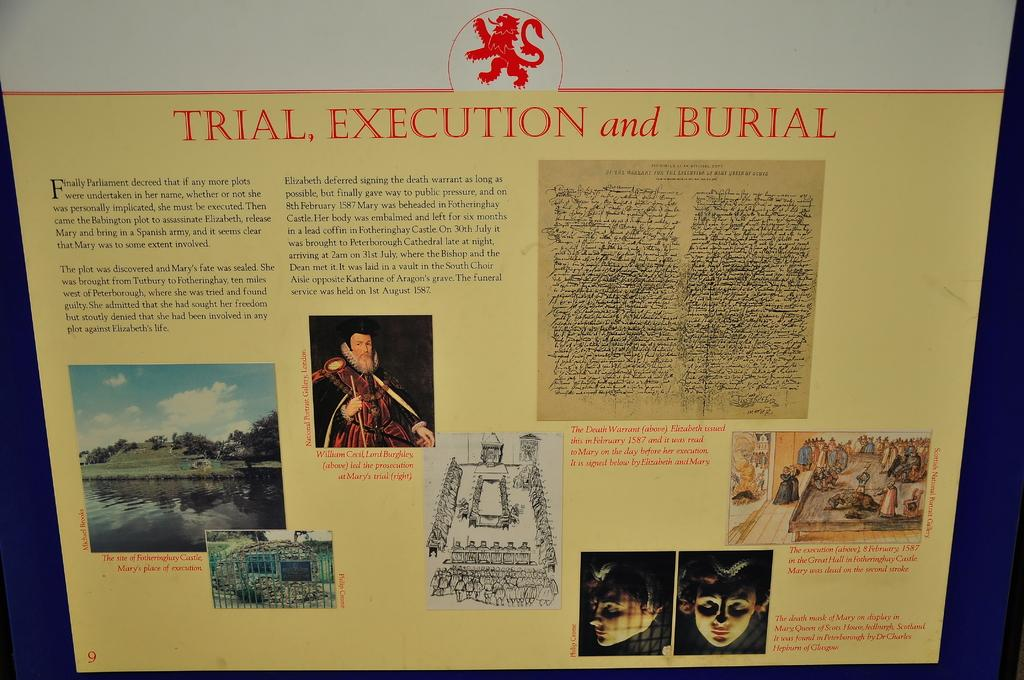<image>
Offer a succinct explanation of the picture presented. a Trial and Execution poster board with info on ut 